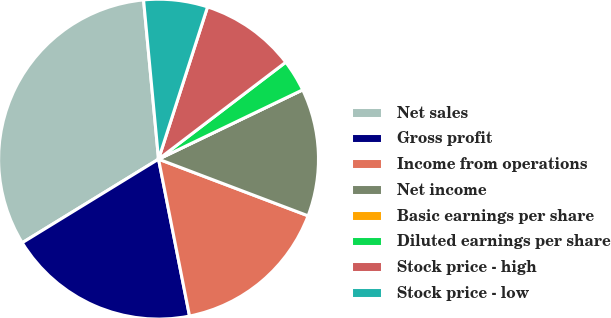<chart> <loc_0><loc_0><loc_500><loc_500><pie_chart><fcel>Net sales<fcel>Gross profit<fcel>Income from operations<fcel>Net income<fcel>Basic earnings per share<fcel>Diluted earnings per share<fcel>Stock price - high<fcel>Stock price - low<nl><fcel>32.26%<fcel>19.35%<fcel>16.13%<fcel>12.9%<fcel>0.0%<fcel>3.23%<fcel>9.68%<fcel>6.45%<nl></chart> 